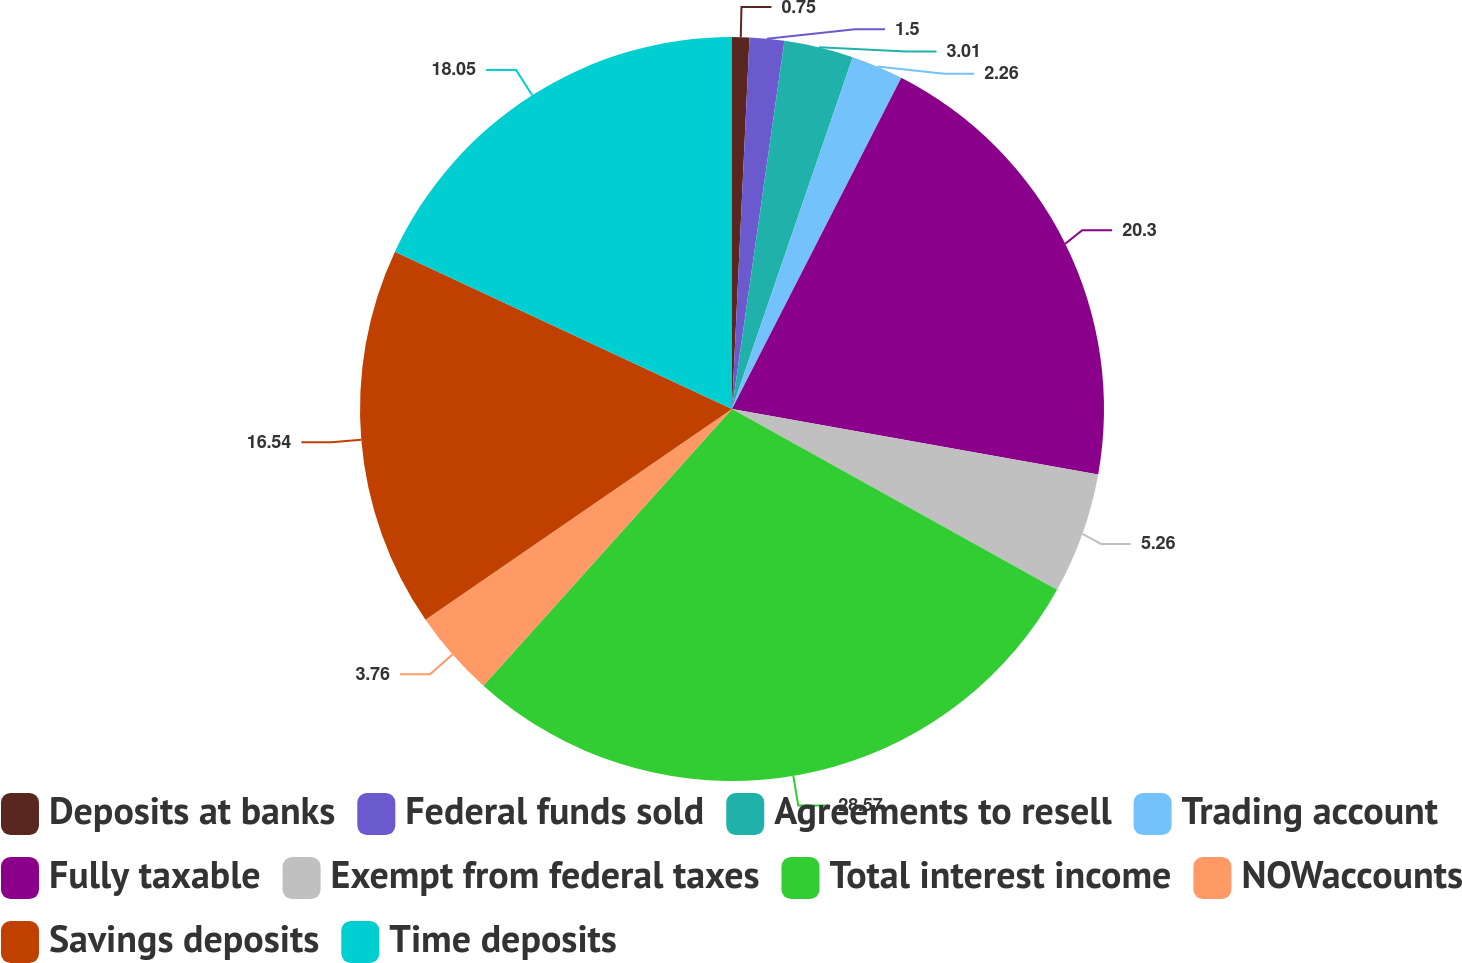<chart> <loc_0><loc_0><loc_500><loc_500><pie_chart><fcel>Deposits at banks<fcel>Federal funds sold<fcel>Agreements to resell<fcel>Trading account<fcel>Fully taxable<fcel>Exempt from federal taxes<fcel>Total interest income<fcel>NOWaccounts<fcel>Savings deposits<fcel>Time deposits<nl><fcel>0.75%<fcel>1.5%<fcel>3.01%<fcel>2.26%<fcel>20.3%<fcel>5.26%<fcel>28.57%<fcel>3.76%<fcel>16.54%<fcel>18.05%<nl></chart> 